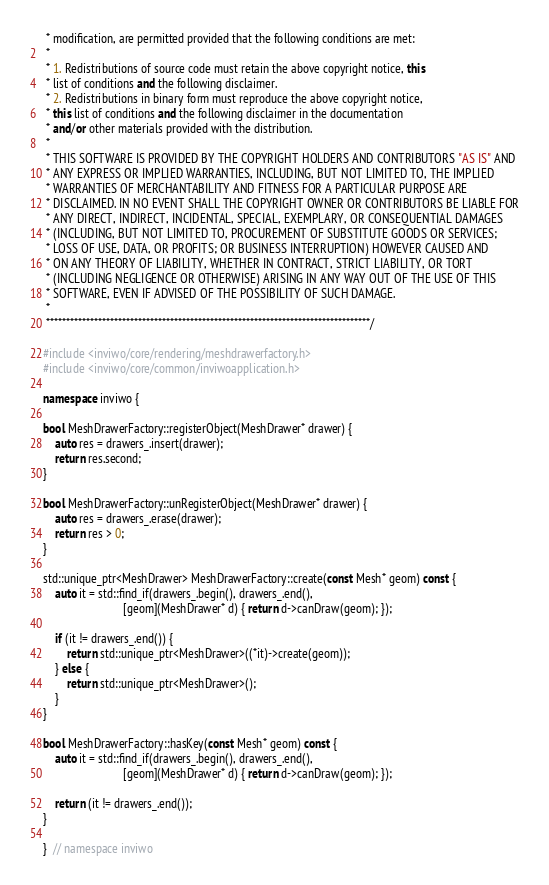Convert code to text. <code><loc_0><loc_0><loc_500><loc_500><_C++_> * modification, are permitted provided that the following conditions are met:
 *
 * 1. Redistributions of source code must retain the above copyright notice, this
 * list of conditions and the following disclaimer.
 * 2. Redistributions in binary form must reproduce the above copyright notice,
 * this list of conditions and the following disclaimer in the documentation
 * and/or other materials provided with the distribution.
 *
 * THIS SOFTWARE IS PROVIDED BY THE COPYRIGHT HOLDERS AND CONTRIBUTORS "AS IS" AND
 * ANY EXPRESS OR IMPLIED WARRANTIES, INCLUDING, BUT NOT LIMITED TO, THE IMPLIED
 * WARRANTIES OF MERCHANTABILITY AND FITNESS FOR A PARTICULAR PURPOSE ARE
 * DISCLAIMED. IN NO EVENT SHALL THE COPYRIGHT OWNER OR CONTRIBUTORS BE LIABLE FOR
 * ANY DIRECT, INDIRECT, INCIDENTAL, SPECIAL, EXEMPLARY, OR CONSEQUENTIAL DAMAGES
 * (INCLUDING, BUT NOT LIMITED TO, PROCUREMENT OF SUBSTITUTE GOODS OR SERVICES;
 * LOSS OF USE, DATA, OR PROFITS; OR BUSINESS INTERRUPTION) HOWEVER CAUSED AND
 * ON ANY THEORY OF LIABILITY, WHETHER IN CONTRACT, STRICT LIABILITY, OR TORT
 * (INCLUDING NEGLIGENCE OR OTHERWISE) ARISING IN ANY WAY OUT OF THE USE OF THIS
 * SOFTWARE, EVEN IF ADVISED OF THE POSSIBILITY OF SUCH DAMAGE.
 *
 *********************************************************************************/

#include <inviwo/core/rendering/meshdrawerfactory.h>
#include <inviwo/core/common/inviwoapplication.h>

namespace inviwo {

bool MeshDrawerFactory::registerObject(MeshDrawer* drawer) {
    auto res = drawers_.insert(drawer);
    return res.second;
}

bool MeshDrawerFactory::unRegisterObject(MeshDrawer* drawer) {
    auto res = drawers_.erase(drawer);
    return res > 0;
}

std::unique_ptr<MeshDrawer> MeshDrawerFactory::create(const Mesh* geom) const {
    auto it = std::find_if(drawers_.begin(), drawers_.end(),
                           [geom](MeshDrawer* d) { return d->canDraw(geom); });

    if (it != drawers_.end()) {
        return std::unique_ptr<MeshDrawer>((*it)->create(geom));
    } else {
        return std::unique_ptr<MeshDrawer>();
    }
}

bool MeshDrawerFactory::hasKey(const Mesh* geom) const {
    auto it = std::find_if(drawers_.begin(), drawers_.end(),
                           [geom](MeshDrawer* d) { return d->canDraw(geom); });

    return (it != drawers_.end());
}

}  // namespace inviwo
</code> 